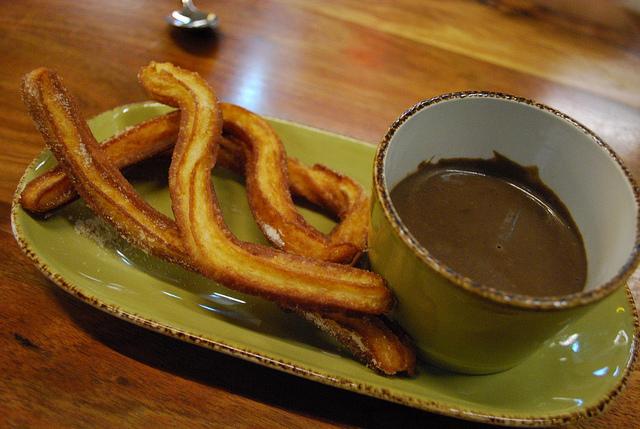What color are the dishes?
Write a very short answer. Green. Is this a well-balanced breakfast?
Short answer required. No. Are this sausages?
Write a very short answer. No. What is the plate sitting on?
Answer briefly. Table. What is present?
Write a very short answer. Churros. What color is the dish?
Concise answer only. Green. What color is in the mug?
Short answer required. Green. What kind of food is this?
Concise answer only. Churro. How many containers are white?
Give a very brief answer. 0. What kind of dish are the cups sitting on?
Quick response, please. Saucer. What color is the plate?
Quick response, please. Green. What kind of food is in this scene?
Answer briefly. Churro. What is in the mug?
Concise answer only. Chocolate. 